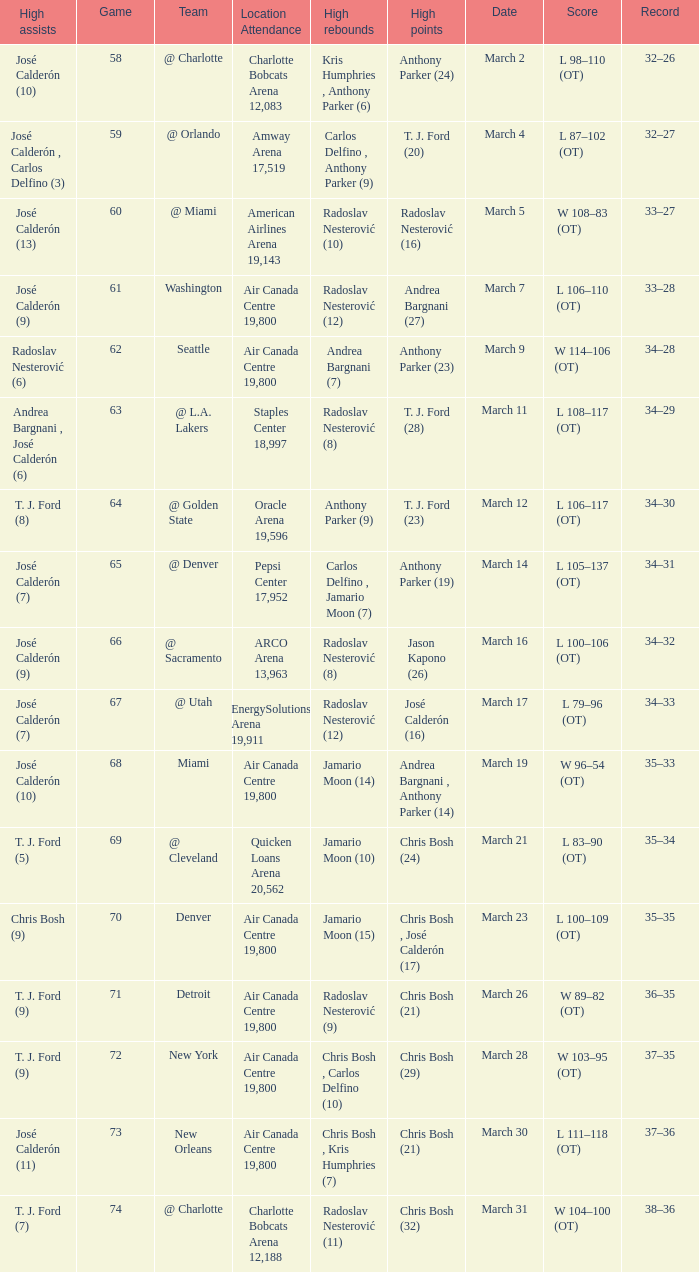Parse the full table. {'header': ['High assists', 'Game', 'Team', 'Location Attendance', 'High rebounds', 'High points', 'Date', 'Score', 'Record'], 'rows': [['José Calderón (10)', '58', '@ Charlotte', 'Charlotte Bobcats Arena 12,083', 'Kris Humphries , Anthony Parker (6)', 'Anthony Parker (24)', 'March 2', 'L 98–110 (OT)', '32–26'], ['José Calderón , Carlos Delfino (3)', '59', '@ Orlando', 'Amway Arena 17,519', 'Carlos Delfino , Anthony Parker (9)', 'T. J. Ford (20)', 'March 4', 'L 87–102 (OT)', '32–27'], ['José Calderón (13)', '60', '@ Miami', 'American Airlines Arena 19,143', 'Radoslav Nesterović (10)', 'Radoslav Nesterović (16)', 'March 5', 'W 108–83 (OT)', '33–27'], ['José Calderón (9)', '61', 'Washington', 'Air Canada Centre 19,800', 'Radoslav Nesterović (12)', 'Andrea Bargnani (27)', 'March 7', 'L 106–110 (OT)', '33–28'], ['Radoslav Nesterović (6)', '62', 'Seattle', 'Air Canada Centre 19,800', 'Andrea Bargnani (7)', 'Anthony Parker (23)', 'March 9', 'W 114–106 (OT)', '34–28'], ['Andrea Bargnani , José Calderón (6)', '63', '@ L.A. Lakers', 'Staples Center 18,997', 'Radoslav Nesterović (8)', 'T. J. Ford (28)', 'March 11', 'L 108–117 (OT)', '34–29'], ['T. J. Ford (8)', '64', '@ Golden State', 'Oracle Arena 19,596', 'Anthony Parker (9)', 'T. J. Ford (23)', 'March 12', 'L 106–117 (OT)', '34–30'], ['José Calderón (7)', '65', '@ Denver', 'Pepsi Center 17,952', 'Carlos Delfino , Jamario Moon (7)', 'Anthony Parker (19)', 'March 14', 'L 105–137 (OT)', '34–31'], ['José Calderón (9)', '66', '@ Sacramento', 'ARCO Arena 13,963', 'Radoslav Nesterović (8)', 'Jason Kapono (26)', 'March 16', 'L 100–106 (OT)', '34–32'], ['José Calderón (7)', '67', '@ Utah', 'EnergySolutions Arena 19,911', 'Radoslav Nesterović (12)', 'José Calderón (16)', 'March 17', 'L 79–96 (OT)', '34–33'], ['José Calderón (10)', '68', 'Miami', 'Air Canada Centre 19,800', 'Jamario Moon (14)', 'Andrea Bargnani , Anthony Parker (14)', 'March 19', 'W 96–54 (OT)', '35–33'], ['T. J. Ford (5)', '69', '@ Cleveland', 'Quicken Loans Arena 20,562', 'Jamario Moon (10)', 'Chris Bosh (24)', 'March 21', 'L 83–90 (OT)', '35–34'], ['Chris Bosh (9)', '70', 'Denver', 'Air Canada Centre 19,800', 'Jamario Moon (15)', 'Chris Bosh , José Calderón (17)', 'March 23', 'L 100–109 (OT)', '35–35'], ['T. J. Ford (9)', '71', 'Detroit', 'Air Canada Centre 19,800', 'Radoslav Nesterović (9)', 'Chris Bosh (21)', 'March 26', 'W 89–82 (OT)', '36–35'], ['T. J. Ford (9)', '72', 'New York', 'Air Canada Centre 19,800', 'Chris Bosh , Carlos Delfino (10)', 'Chris Bosh (29)', 'March 28', 'W 103–95 (OT)', '37–35'], ['José Calderón (11)', '73', 'New Orleans', 'Air Canada Centre 19,800', 'Chris Bosh , Kris Humphries (7)', 'Chris Bosh (21)', 'March 30', 'L 111–118 (OT)', '37–36'], ['T. J. Ford (7)', '74', '@ Charlotte', 'Charlotte Bobcats Arena 12,188', 'Radoslav Nesterović (11)', 'Chris Bosh (32)', 'March 31', 'W 104–100 (OT)', '38–36']]} What numbered game featured a High rebounds of radoslav nesterović (8), and a High assists of josé calderón (9)? 1.0. 